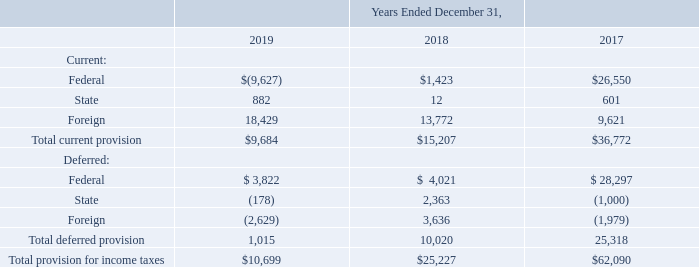ADVANCED ENERGY INDUSTRIES, INC. NOTES TO CONSOLIDATED FINANCIAL STATEMENTS – (continued) (in thousands, except per share amounts)
The provision for income taxes from continuing operations is summarized as follows:
The Company’s effective tax rates differ from the U.S. federal statutory rate of 21% for the years ended December 31, 2019 and December 31, 2018, primarily due to the benefit of tax credits and earnings in foreign jurisdictions which are subject to lower tax rates, offset by additional GILTI tax in the US and withholding taxes.
Which periods does the company's effective tax rates differ from the U.S. federal statutory rate? December 31, 2019, december 31, 2018. What was the current provision for Federal taxes in 2018?
Answer scale should be: thousand. $1,423. What was the current provision for Foreign taxes in 2019?
Answer scale should be: thousand. 18,429. What was the change in total current provision between 2017 and 2018?
Answer scale should be: thousand. $15,207-$36,772
Answer: -21565. What was the change in Total deferred provision between 2018 and 2019?
Answer scale should be: thousand. 1,015-10,020
Answer: -9005. What was the percentage change in total provision for income taxes between 2017 and 2018?
Answer scale should be: percent. ($25,227-$62,090)/$62,090
Answer: -59.37. 